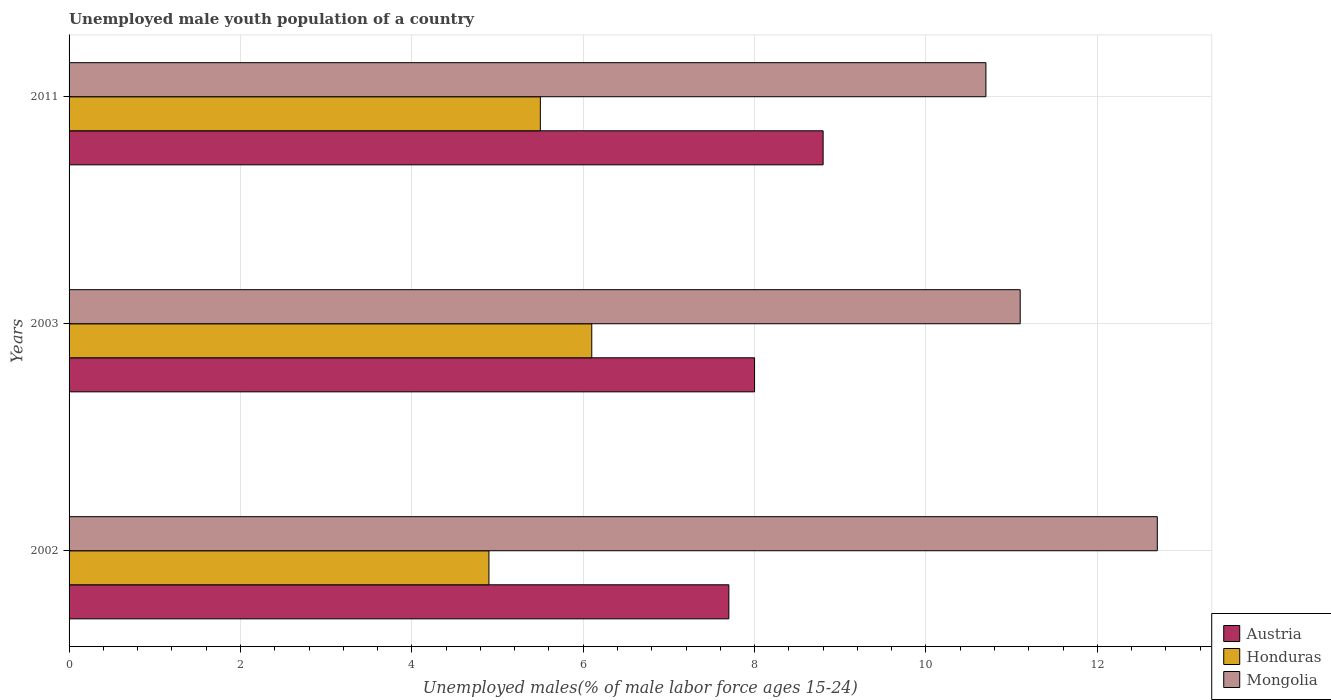In how many cases, is the number of bars for a given year not equal to the number of legend labels?
Offer a terse response. 0. What is the percentage of unemployed male youth population in Austria in 2003?
Make the answer very short. 8. Across all years, what is the maximum percentage of unemployed male youth population in Honduras?
Make the answer very short. 6.1. Across all years, what is the minimum percentage of unemployed male youth population in Austria?
Make the answer very short. 7.7. In which year was the percentage of unemployed male youth population in Honduras maximum?
Provide a succinct answer. 2003. In which year was the percentage of unemployed male youth population in Honduras minimum?
Ensure brevity in your answer.  2002. What is the total percentage of unemployed male youth population in Mongolia in the graph?
Keep it short and to the point. 34.5. What is the difference between the percentage of unemployed male youth population in Mongolia in 2003 and that in 2011?
Your response must be concise. 0.4. What is the difference between the percentage of unemployed male youth population in Mongolia in 2003 and the percentage of unemployed male youth population in Honduras in 2002?
Your answer should be very brief. 6.2. In the year 2011, what is the difference between the percentage of unemployed male youth population in Mongolia and percentage of unemployed male youth population in Austria?
Provide a succinct answer. 1.9. In how many years, is the percentage of unemployed male youth population in Austria greater than 10 %?
Offer a very short reply. 0. What is the ratio of the percentage of unemployed male youth population in Mongolia in 2002 to that in 2011?
Your answer should be compact. 1.19. Is the percentage of unemployed male youth population in Mongolia in 2002 less than that in 2011?
Ensure brevity in your answer.  No. Is the difference between the percentage of unemployed male youth population in Mongolia in 2002 and 2011 greater than the difference between the percentage of unemployed male youth population in Austria in 2002 and 2011?
Provide a succinct answer. Yes. What is the difference between the highest and the second highest percentage of unemployed male youth population in Austria?
Offer a very short reply. 0.8. What is the difference between the highest and the lowest percentage of unemployed male youth population in Honduras?
Make the answer very short. 1.2. In how many years, is the percentage of unemployed male youth population in Austria greater than the average percentage of unemployed male youth population in Austria taken over all years?
Your response must be concise. 1. Is the sum of the percentage of unemployed male youth population in Austria in 2002 and 2003 greater than the maximum percentage of unemployed male youth population in Mongolia across all years?
Ensure brevity in your answer.  Yes. What does the 1st bar from the bottom in 2002 represents?
Provide a succinct answer. Austria. How many years are there in the graph?
Your answer should be compact. 3. What is the difference between two consecutive major ticks on the X-axis?
Provide a short and direct response. 2. Where does the legend appear in the graph?
Your answer should be compact. Bottom right. What is the title of the graph?
Provide a succinct answer. Unemployed male youth population of a country. What is the label or title of the X-axis?
Provide a short and direct response. Unemployed males(% of male labor force ages 15-24). What is the Unemployed males(% of male labor force ages 15-24) in Austria in 2002?
Your response must be concise. 7.7. What is the Unemployed males(% of male labor force ages 15-24) of Honduras in 2002?
Ensure brevity in your answer.  4.9. What is the Unemployed males(% of male labor force ages 15-24) in Mongolia in 2002?
Make the answer very short. 12.7. What is the Unemployed males(% of male labor force ages 15-24) of Honduras in 2003?
Make the answer very short. 6.1. What is the Unemployed males(% of male labor force ages 15-24) of Mongolia in 2003?
Offer a terse response. 11.1. What is the Unemployed males(% of male labor force ages 15-24) of Austria in 2011?
Ensure brevity in your answer.  8.8. What is the Unemployed males(% of male labor force ages 15-24) in Mongolia in 2011?
Your answer should be compact. 10.7. Across all years, what is the maximum Unemployed males(% of male labor force ages 15-24) in Austria?
Your response must be concise. 8.8. Across all years, what is the maximum Unemployed males(% of male labor force ages 15-24) in Honduras?
Ensure brevity in your answer.  6.1. Across all years, what is the maximum Unemployed males(% of male labor force ages 15-24) in Mongolia?
Provide a succinct answer. 12.7. Across all years, what is the minimum Unemployed males(% of male labor force ages 15-24) of Austria?
Offer a terse response. 7.7. Across all years, what is the minimum Unemployed males(% of male labor force ages 15-24) of Honduras?
Offer a very short reply. 4.9. Across all years, what is the minimum Unemployed males(% of male labor force ages 15-24) in Mongolia?
Ensure brevity in your answer.  10.7. What is the total Unemployed males(% of male labor force ages 15-24) in Mongolia in the graph?
Your answer should be compact. 34.5. What is the difference between the Unemployed males(% of male labor force ages 15-24) of Austria in 2002 and that in 2003?
Your answer should be compact. -0.3. What is the difference between the Unemployed males(% of male labor force ages 15-24) of Honduras in 2002 and that in 2003?
Make the answer very short. -1.2. What is the difference between the Unemployed males(% of male labor force ages 15-24) in Austria in 2002 and that in 2011?
Your answer should be compact. -1.1. What is the difference between the Unemployed males(% of male labor force ages 15-24) in Mongolia in 2002 and that in 2011?
Give a very brief answer. 2. What is the difference between the Unemployed males(% of male labor force ages 15-24) in Austria in 2003 and that in 2011?
Provide a short and direct response. -0.8. What is the difference between the Unemployed males(% of male labor force ages 15-24) of Honduras in 2003 and that in 2011?
Offer a very short reply. 0.6. What is the difference between the Unemployed males(% of male labor force ages 15-24) of Mongolia in 2003 and that in 2011?
Offer a very short reply. 0.4. What is the difference between the Unemployed males(% of male labor force ages 15-24) in Austria in 2002 and the Unemployed males(% of male labor force ages 15-24) in Honduras in 2003?
Provide a short and direct response. 1.6. What is the difference between the Unemployed males(% of male labor force ages 15-24) in Austria in 2002 and the Unemployed males(% of male labor force ages 15-24) in Mongolia in 2003?
Your answer should be compact. -3.4. What is the difference between the Unemployed males(% of male labor force ages 15-24) of Austria in 2002 and the Unemployed males(% of male labor force ages 15-24) of Honduras in 2011?
Give a very brief answer. 2.2. What is the difference between the Unemployed males(% of male labor force ages 15-24) in Honduras in 2002 and the Unemployed males(% of male labor force ages 15-24) in Mongolia in 2011?
Provide a short and direct response. -5.8. What is the difference between the Unemployed males(% of male labor force ages 15-24) of Austria in 2003 and the Unemployed males(% of male labor force ages 15-24) of Honduras in 2011?
Make the answer very short. 2.5. What is the difference between the Unemployed males(% of male labor force ages 15-24) in Honduras in 2003 and the Unemployed males(% of male labor force ages 15-24) in Mongolia in 2011?
Your response must be concise. -4.6. What is the average Unemployed males(% of male labor force ages 15-24) in Austria per year?
Keep it short and to the point. 8.17. What is the average Unemployed males(% of male labor force ages 15-24) in Honduras per year?
Ensure brevity in your answer.  5.5. In the year 2002, what is the difference between the Unemployed males(% of male labor force ages 15-24) of Austria and Unemployed males(% of male labor force ages 15-24) of Honduras?
Provide a succinct answer. 2.8. In the year 2002, what is the difference between the Unemployed males(% of male labor force ages 15-24) of Austria and Unemployed males(% of male labor force ages 15-24) of Mongolia?
Your answer should be compact. -5. In the year 2003, what is the difference between the Unemployed males(% of male labor force ages 15-24) of Austria and Unemployed males(% of male labor force ages 15-24) of Honduras?
Provide a short and direct response. 1.9. In the year 2003, what is the difference between the Unemployed males(% of male labor force ages 15-24) in Austria and Unemployed males(% of male labor force ages 15-24) in Mongolia?
Offer a terse response. -3.1. In the year 2003, what is the difference between the Unemployed males(% of male labor force ages 15-24) in Honduras and Unemployed males(% of male labor force ages 15-24) in Mongolia?
Make the answer very short. -5. In the year 2011, what is the difference between the Unemployed males(% of male labor force ages 15-24) in Honduras and Unemployed males(% of male labor force ages 15-24) in Mongolia?
Provide a succinct answer. -5.2. What is the ratio of the Unemployed males(% of male labor force ages 15-24) of Austria in 2002 to that in 2003?
Offer a terse response. 0.96. What is the ratio of the Unemployed males(% of male labor force ages 15-24) of Honduras in 2002 to that in 2003?
Keep it short and to the point. 0.8. What is the ratio of the Unemployed males(% of male labor force ages 15-24) of Mongolia in 2002 to that in 2003?
Provide a succinct answer. 1.14. What is the ratio of the Unemployed males(% of male labor force ages 15-24) in Austria in 2002 to that in 2011?
Your answer should be very brief. 0.88. What is the ratio of the Unemployed males(% of male labor force ages 15-24) of Honduras in 2002 to that in 2011?
Give a very brief answer. 0.89. What is the ratio of the Unemployed males(% of male labor force ages 15-24) in Mongolia in 2002 to that in 2011?
Your response must be concise. 1.19. What is the ratio of the Unemployed males(% of male labor force ages 15-24) in Austria in 2003 to that in 2011?
Your answer should be compact. 0.91. What is the ratio of the Unemployed males(% of male labor force ages 15-24) of Honduras in 2003 to that in 2011?
Your response must be concise. 1.11. What is the ratio of the Unemployed males(% of male labor force ages 15-24) of Mongolia in 2003 to that in 2011?
Your response must be concise. 1.04. What is the difference between the highest and the second highest Unemployed males(% of male labor force ages 15-24) in Austria?
Ensure brevity in your answer.  0.8. What is the difference between the highest and the second highest Unemployed males(% of male labor force ages 15-24) in Mongolia?
Your answer should be compact. 1.6. What is the difference between the highest and the lowest Unemployed males(% of male labor force ages 15-24) in Honduras?
Provide a succinct answer. 1.2. What is the difference between the highest and the lowest Unemployed males(% of male labor force ages 15-24) in Mongolia?
Your response must be concise. 2. 